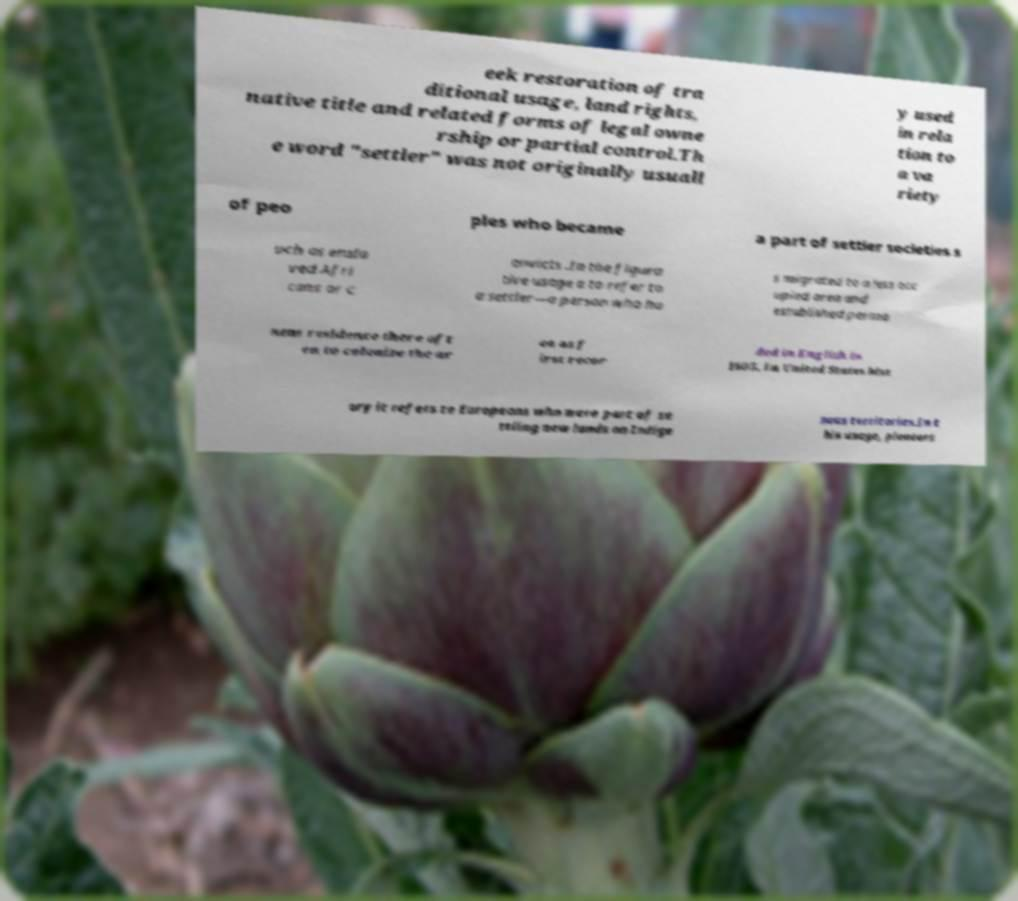Can you read and provide the text displayed in the image?This photo seems to have some interesting text. Can you extract and type it out for me? eek restoration of tra ditional usage, land rights, native title and related forms of legal owne rship or partial control.Th e word "settler" was not originally usuall y used in rela tion to a va riety of peo ples who became a part of settler societies s uch as ensla ved Afri cans or c onvicts .In the figura tive usage a to refer to a settler—a person who ha s migrated to a less occ upied area and established perma nent residence there oft en to colonize the ar ea as f irst recor ded in English in 1605. In United States hist ory it refers to Europeans who were part of se ttling new lands on Indige nous territories.In t his usage, pioneers 